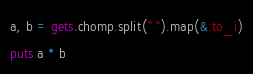Convert code to text. <code><loc_0><loc_0><loc_500><loc_500><_Ruby_>a, b = gets.chomp.split(" ").map(&:to_i)
puts a * b

</code> 